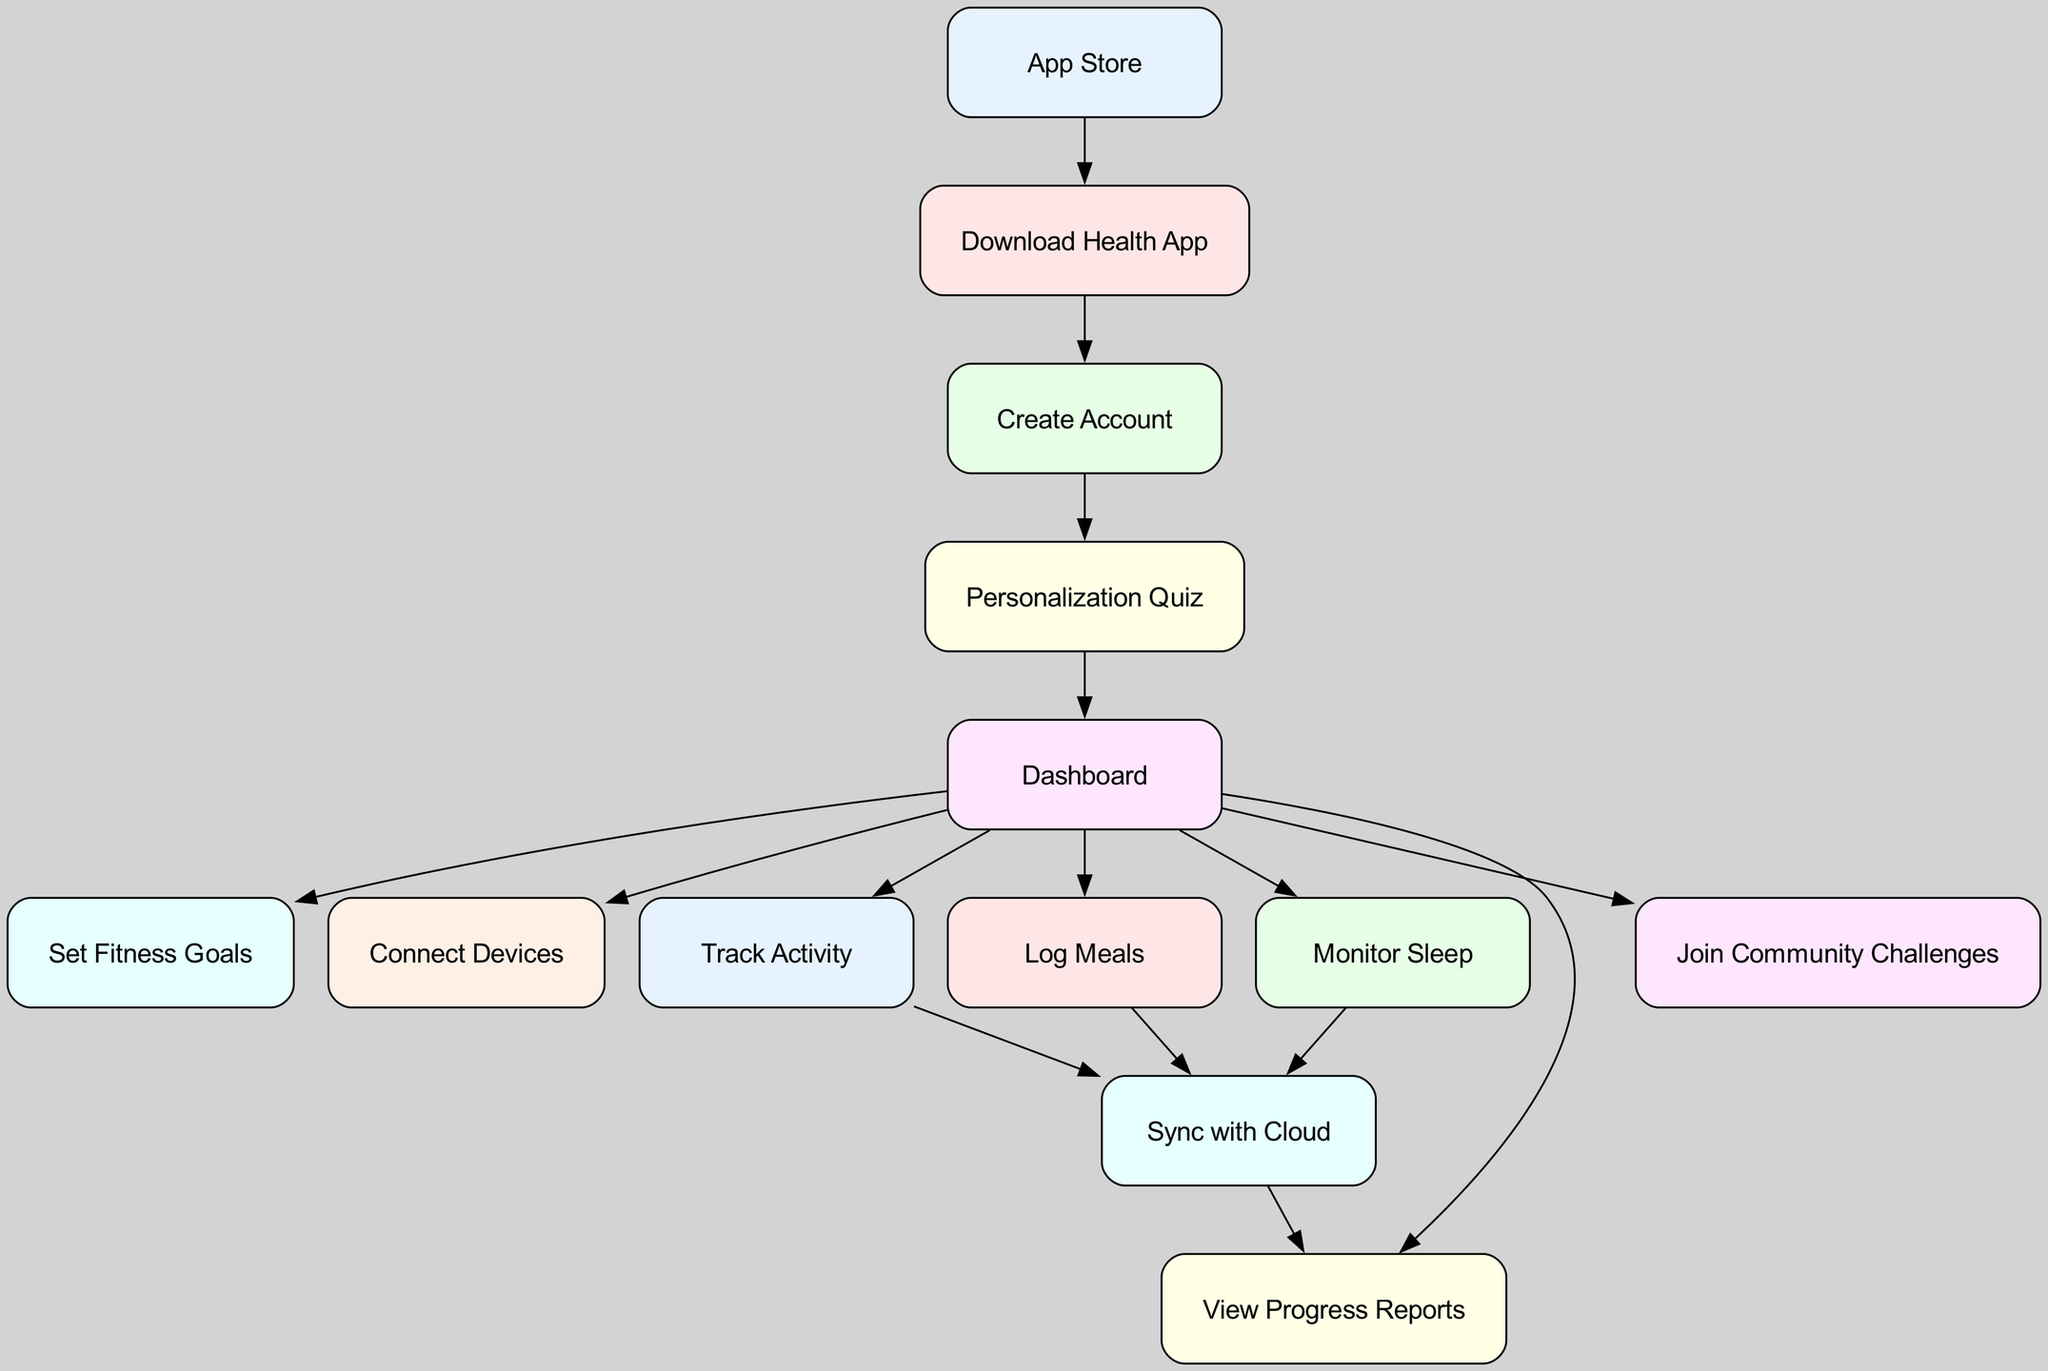What is the first step in the user journey? The first step is represented by the "App Store" node, which is the starting point of the user journey before downloading the health app.
Answer: App Store How many nodes are in the diagram? By counting all items in the nodes list, there are a total of 13 distinct steps or features included in the user journey visualized in the diagram.
Answer: 13 Which node comes after "Create Account"? The diagram indicates that following "Create Account," the next step is "Personalization Quiz," as illustrated by the directed edge connecting these two nodes.
Answer: Personalization Quiz What feature can be accessed directly from the "Dashboard"? The node "Set Fitness Goals" can be accessed directly from the "Dashboard," as there is a direct edge indicating this connection.
Answer: Set Fitness Goals How many features lead directly from the "Dashboard"? The "Dashboard" node has six direct outgoing edges, each connecting to a different feature or action one can take.
Answer: 6 Which two nodes connect to "Sync with Cloud"? The diagram shows that "Track Activity" and "Log Meals" both connect to "Sync with Cloud," meaning these two actions directly lead to syncing data with the cloud.
Answer: Track Activity, Log Meals What is the last node that is reached after syncing with the cloud? After "Sync with Cloud," the next and final node reached is "View Progress Reports," indicating that progress can be reviewed after syncing data.
Answer: View Progress Reports What step follows the "Personalization Quiz"? The flow shows that after completing the "Personalization Quiz," the user is directed to the "Dashboard," making it the next step in the process.
Answer: Dashboard Which action is related to sleep tracking in the user journey? The diagram includes "Monitor Sleep" as a specific action related to sleep tracking, which is highlighted as a critical feature within the app.
Answer: Monitor Sleep 